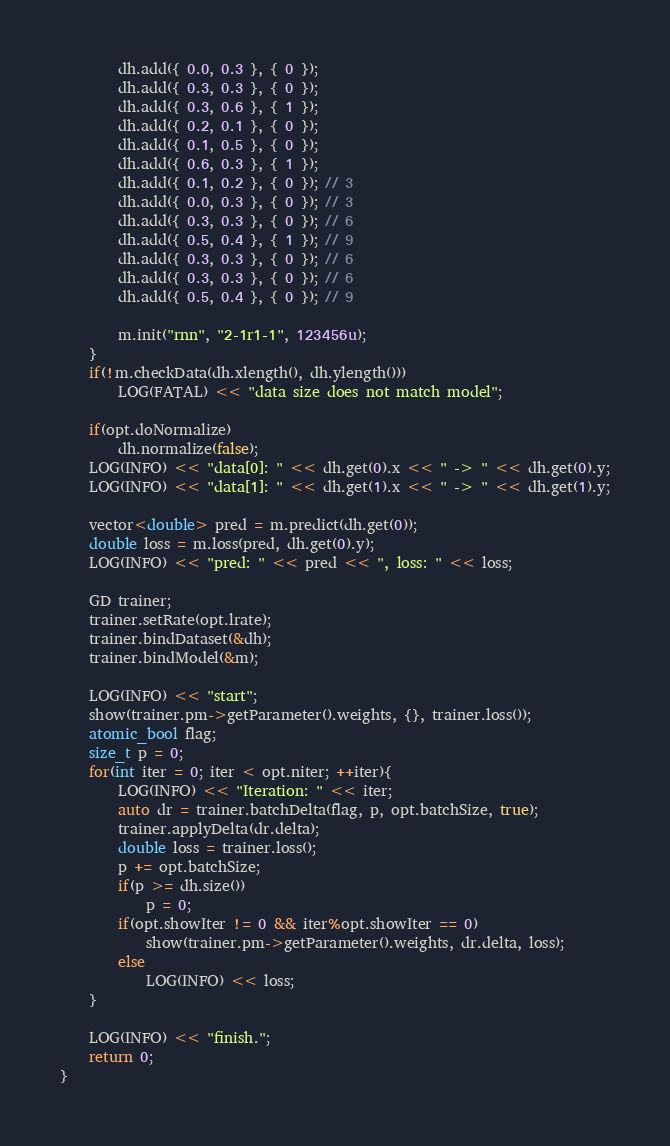Convert code to text. <code><loc_0><loc_0><loc_500><loc_500><_C++_>		dh.add({ 0.0, 0.3 }, { 0 });
		dh.add({ 0.3, 0.3 }, { 0 });
		dh.add({ 0.3, 0.6 }, { 1 });
		dh.add({ 0.2, 0.1 }, { 0 });
		dh.add({ 0.1, 0.5 }, { 0 });
		dh.add({ 0.6, 0.3 }, { 1 });
		dh.add({ 0.1, 0.2 }, { 0 }); // 3
		dh.add({ 0.0, 0.3 }, { 0 }); // 3
		dh.add({ 0.3, 0.3 }, { 0 }); // 6
		dh.add({ 0.5, 0.4 }, { 1 }); // 9
		dh.add({ 0.3, 0.3 }, { 0 }); // 6
		dh.add({ 0.3, 0.3 }, { 0 }); // 6
		dh.add({ 0.5, 0.4 }, { 0 }); // 9

		m.init("rnn", "2-1r1-1", 123456u);
	}
	if(!m.checkData(dh.xlength(), dh.ylength()))
		LOG(FATAL) << "data size does not match model";

	if(opt.doNormalize)
		dh.normalize(false);
	LOG(INFO) << "data[0]: " << dh.get(0).x << " -> " << dh.get(0).y;
	LOG(INFO) << "data[1]: " << dh.get(1).x << " -> " << dh.get(1).y;

	vector<double> pred = m.predict(dh.get(0));
	double loss = m.loss(pred, dh.get(0).y);
	LOG(INFO) << "pred: " << pred << ", loss: " << loss;

	GD trainer;
	trainer.setRate(opt.lrate);
	trainer.bindDataset(&dh);
	trainer.bindModel(&m);

	LOG(INFO) << "start";
	show(trainer.pm->getParameter().weights, {}, trainer.loss());
	atomic_bool flag;
	size_t p = 0;
	for(int iter = 0; iter < opt.niter; ++iter){
		LOG(INFO) << "Iteration: " << iter;
		auto dr = trainer.batchDelta(flag, p, opt.batchSize, true);
		trainer.applyDelta(dr.delta);
		double loss = trainer.loss();
		p += opt.batchSize;
		if(p >= dh.size())
			p = 0;
		if(opt.showIter != 0 && iter%opt.showIter == 0)
			show(trainer.pm->getParameter().weights, dr.delta, loss);
		else
			LOG(INFO) << loss;
	}

	LOG(INFO) << "finish.";
	return 0;
}
</code> 